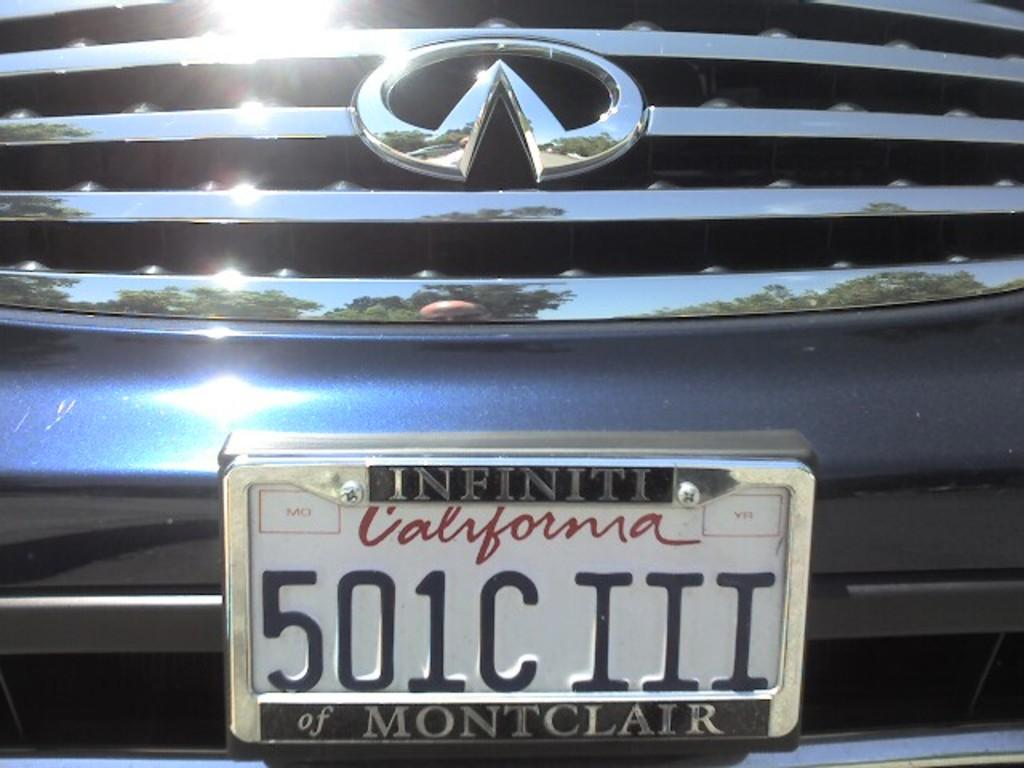<image>
Share a concise interpretation of the image provided. The closeup of the California license plates shows the holder is from the Infiniti dealer of Montclair. 